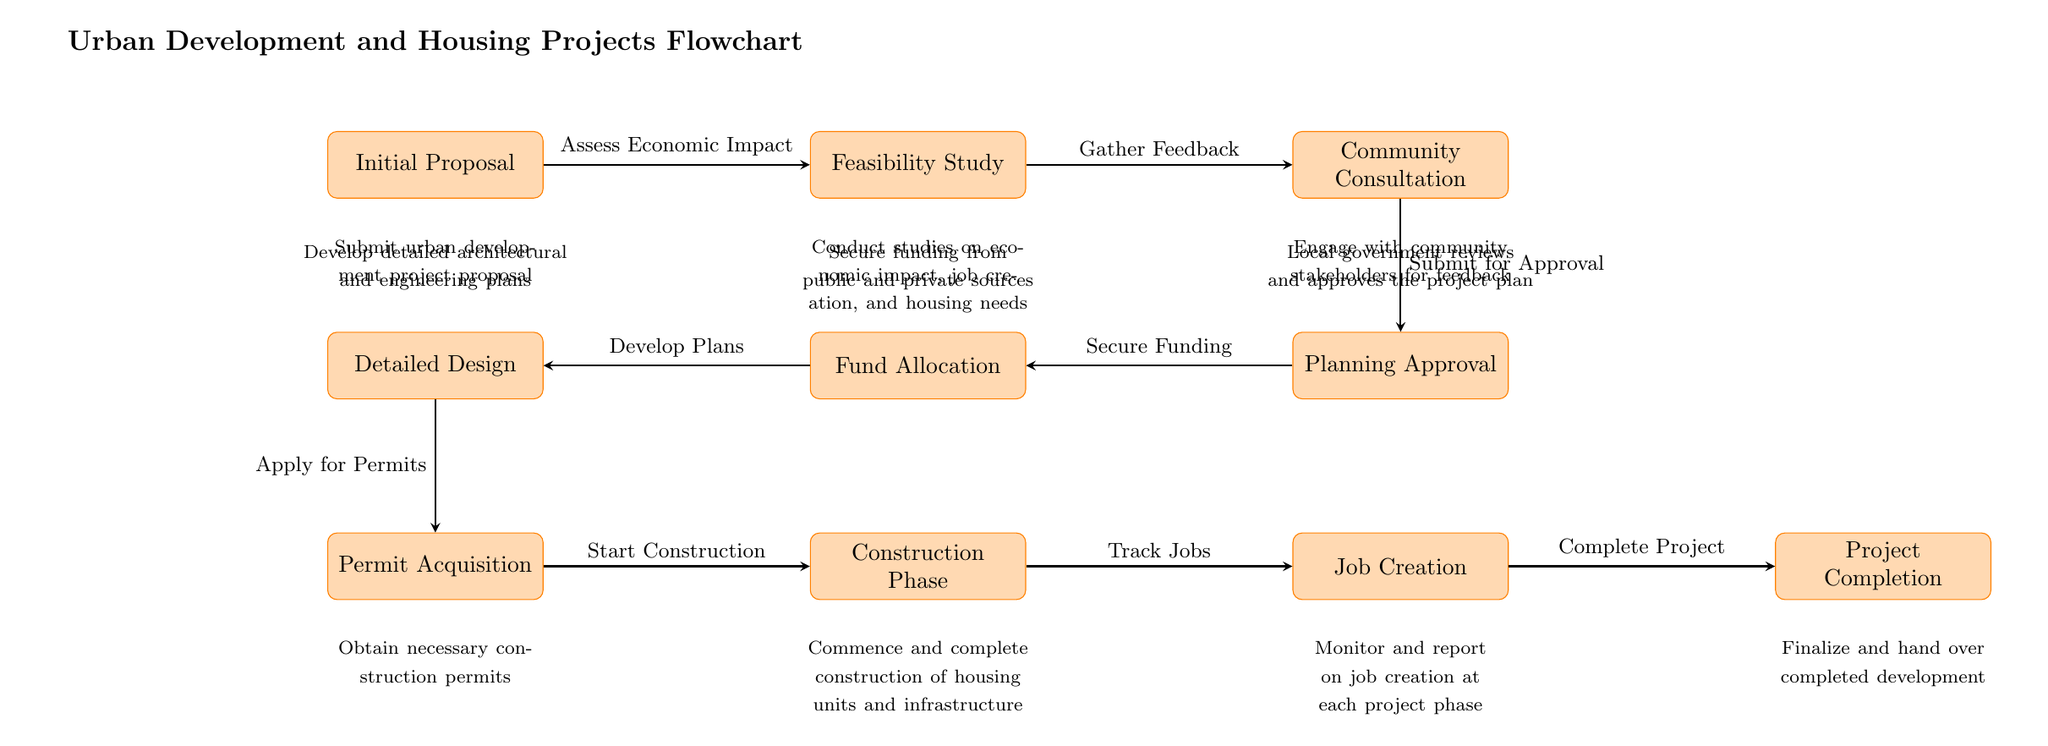What is the first step in the flowchart? The first step shown in the flowchart is "Initial Proposal," indicating that the process begins with submitting an urban development project proposal.
Answer: Initial Proposal How many main steps are in the flowchart? The flowchart displays a total of eight main steps, from "Initial Proposal" to "Project Completion," indicating the complete process for urban development and housing projects.
Answer: Eight What is the last step in the flowchart? The last step is "Project Completion," which signifies the final stage in the urban development process where the project is finalized and handed over.
Answer: Project Completion What connects "Feasibility Study" to "Community Consultation"? The two nodes are connected by an arrow labeled "Gather Feedback," indicating that feedback is collected after the feasibility studies are completed before moving onto community consultation.
Answer: Gather Feedback Which step comes after "Construction Phase"? The step that follows "Construction Phase" is "Job Creation," indicating that job tracking occurs post-construction.
Answer: Job Creation What is assessed during the "Initial Proposal" step? During the "Initial Proposal" step, the "Economic Impact" is assessed as indicated by the arrow linking "Initial Proposal" to "Feasibility Study."
Answer: Economic Impact What is required before "Start Construction"? Before starting the construction, "Permit Acquisition" is necessary, which indicates that obtaining the required permits is a crucial step prior to construction initiation.
Answer: Permit Acquisition How does "Community Consultation" impact "Planning Approval"? After gathering feedback during "Community Consultation," that feedback is submitted for approval, making it a crucial part of the planning approval process.
Answer: Submit for Approval 